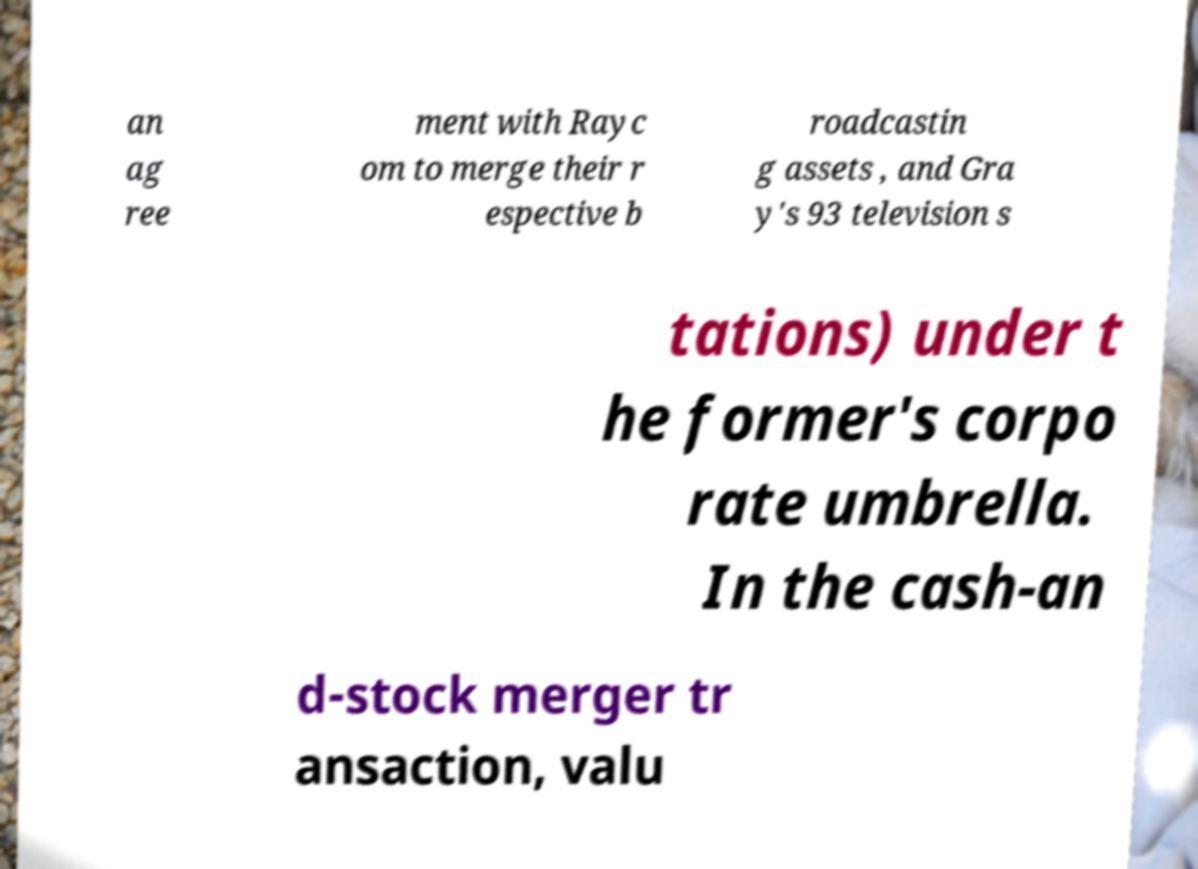Could you extract and type out the text from this image? an ag ree ment with Rayc om to merge their r espective b roadcastin g assets , and Gra y's 93 television s tations) under t he former's corpo rate umbrella. In the cash-an d-stock merger tr ansaction, valu 